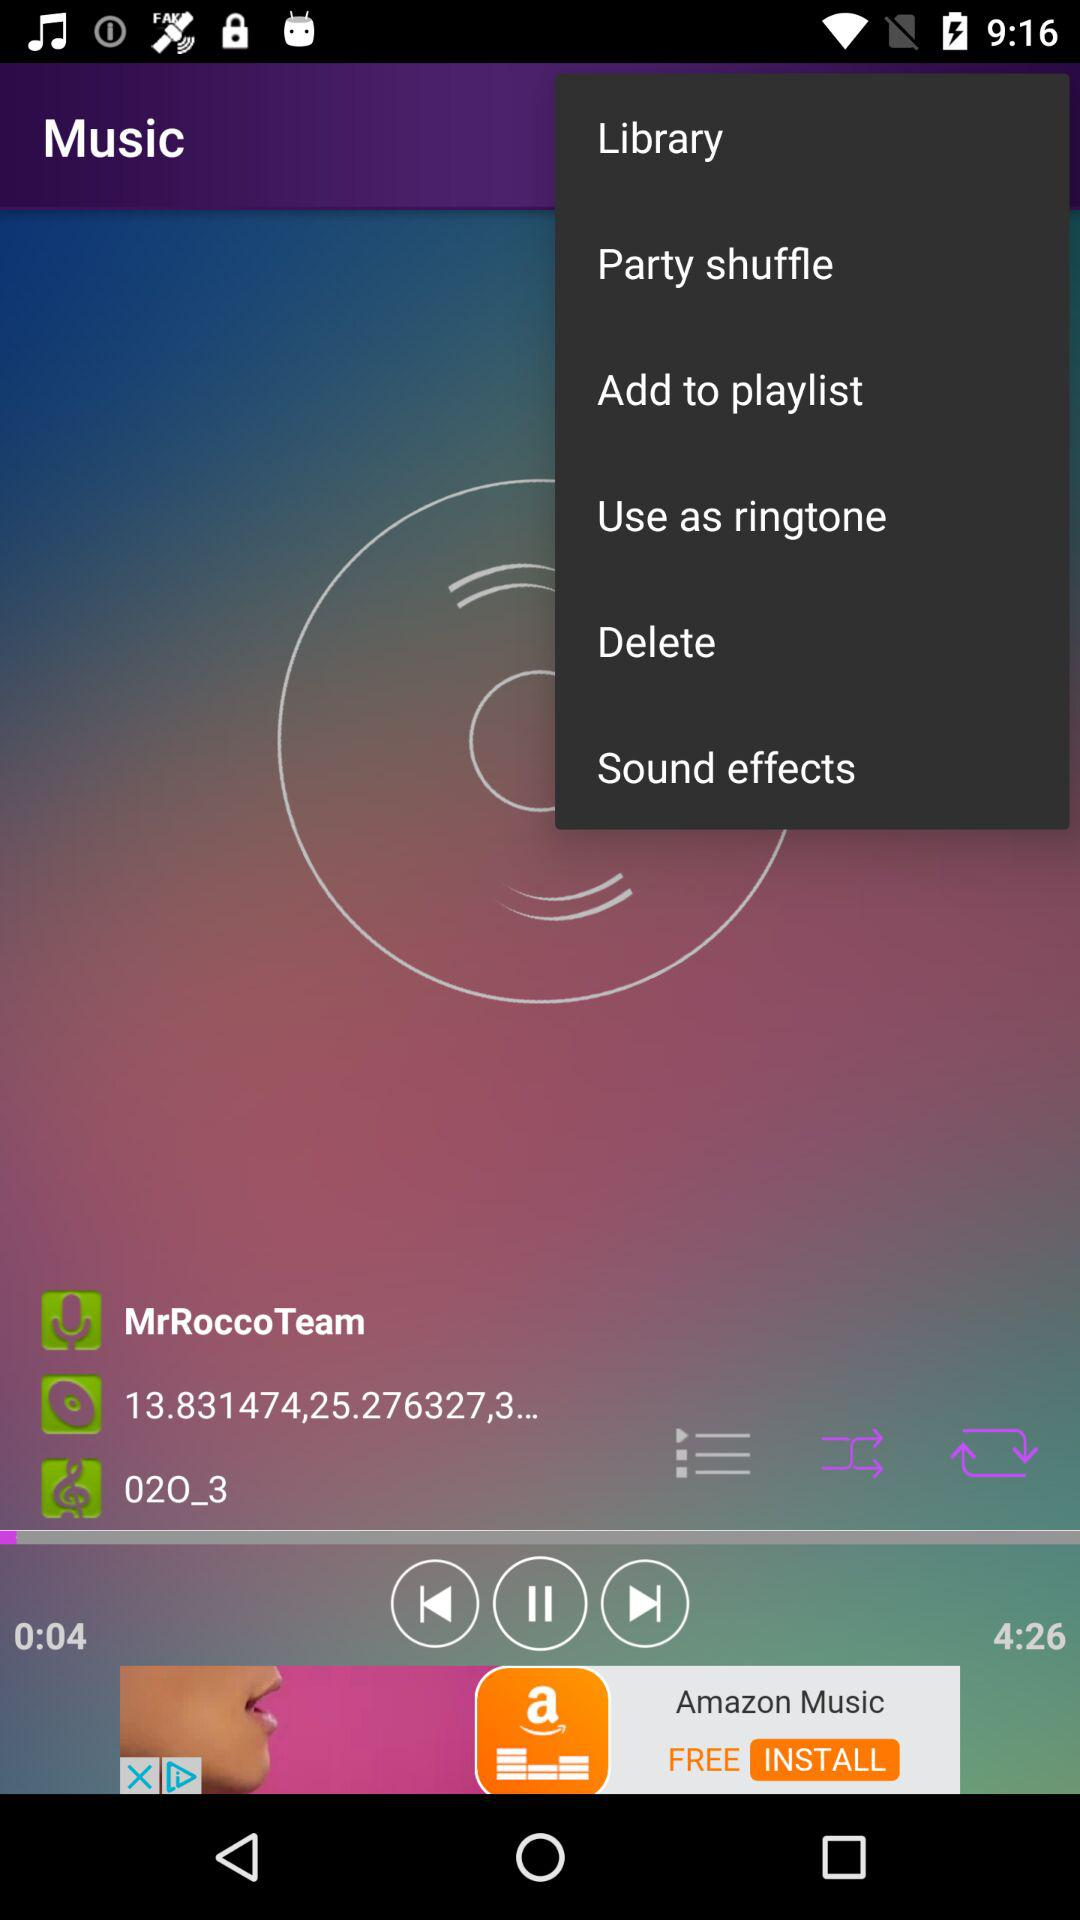How long has the song been playing? The song has been playing for 4 seconds. 